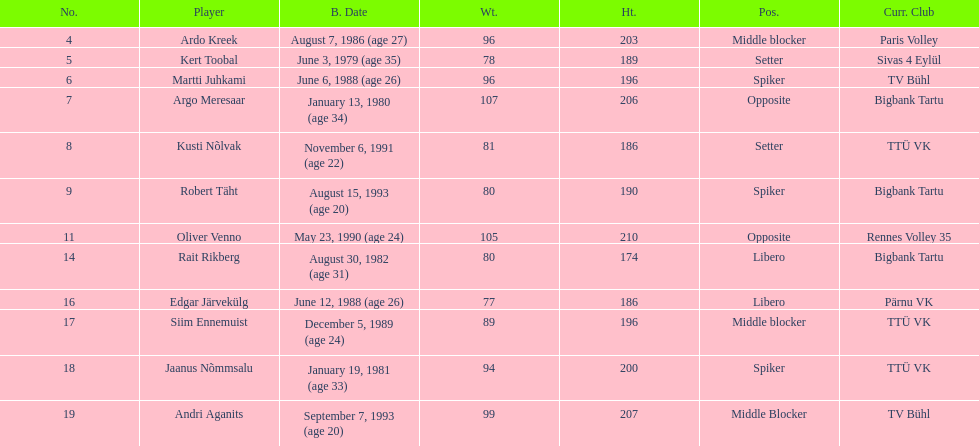Who is the tallest member of estonia's men's national volleyball team? Oliver Venno. 